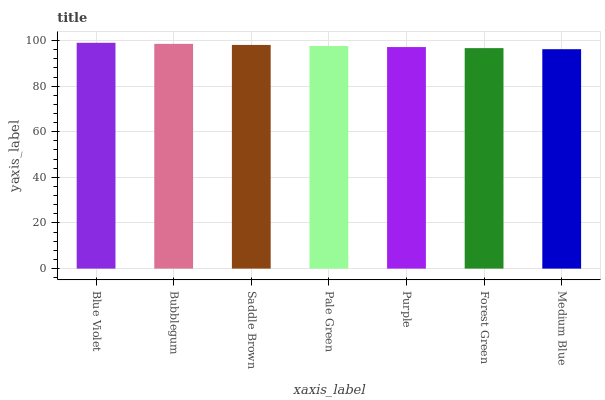Is Medium Blue the minimum?
Answer yes or no. Yes. Is Blue Violet the maximum?
Answer yes or no. Yes. Is Bubblegum the minimum?
Answer yes or no. No. Is Bubblegum the maximum?
Answer yes or no. No. Is Blue Violet greater than Bubblegum?
Answer yes or no. Yes. Is Bubblegum less than Blue Violet?
Answer yes or no. Yes. Is Bubblegum greater than Blue Violet?
Answer yes or no. No. Is Blue Violet less than Bubblegum?
Answer yes or no. No. Is Pale Green the high median?
Answer yes or no. Yes. Is Pale Green the low median?
Answer yes or no. Yes. Is Medium Blue the high median?
Answer yes or no. No. Is Saddle Brown the low median?
Answer yes or no. No. 